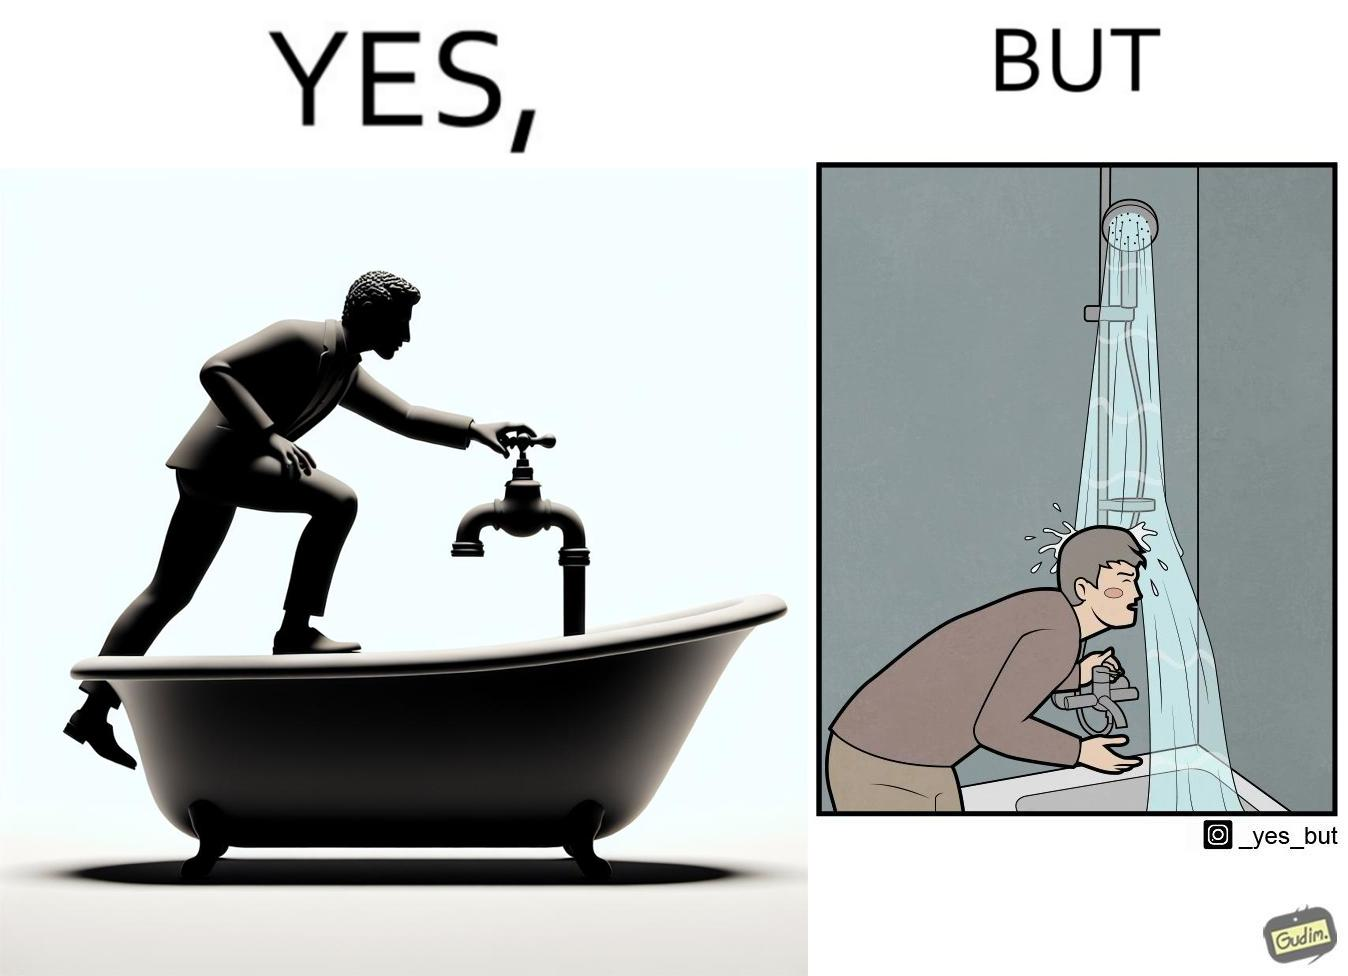Describe what you see in the left and right parts of this image. In the left part of the image: A person operating a tap on top of a bathtub. In the right part of the image: A person operating a tap on top of the bathtub, while water is pouring down on the person from the handheld shower rested upon a holder. 